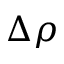<formula> <loc_0><loc_0><loc_500><loc_500>\Delta \rho</formula> 